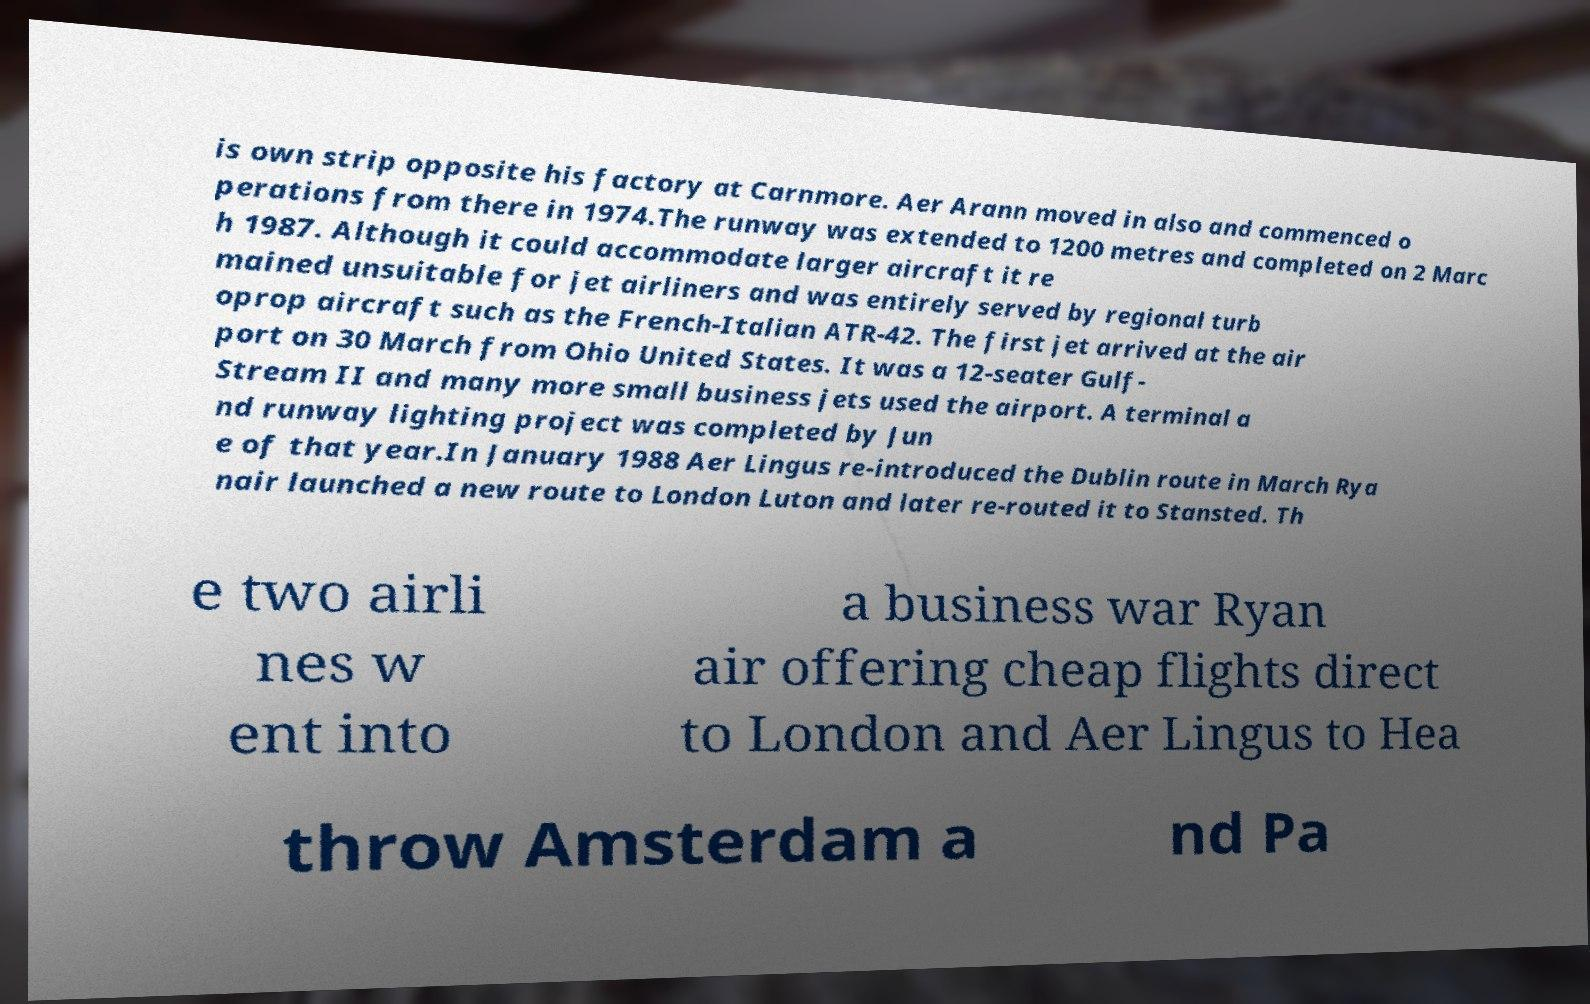Can you accurately transcribe the text from the provided image for me? is own strip opposite his factory at Carnmore. Aer Arann moved in also and commenced o perations from there in 1974.The runway was extended to 1200 metres and completed on 2 Marc h 1987. Although it could accommodate larger aircraft it re mained unsuitable for jet airliners and was entirely served by regional turb oprop aircraft such as the French-Italian ATR-42. The first jet arrived at the air port on 30 March from Ohio United States. It was a 12-seater Gulf- Stream II and many more small business jets used the airport. A terminal a nd runway lighting project was completed by Jun e of that year.In January 1988 Aer Lingus re-introduced the Dublin route in March Rya nair launched a new route to London Luton and later re-routed it to Stansted. Th e two airli nes w ent into a business war Ryan air offering cheap flights direct to London and Aer Lingus to Hea throw Amsterdam a nd Pa 